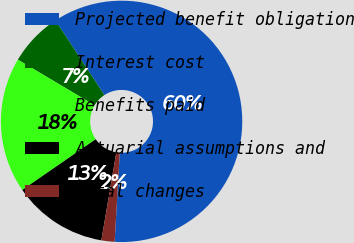Convert chart. <chart><loc_0><loc_0><loc_500><loc_500><pie_chart><fcel>Projected benefit obligation<fcel>Interest cost<fcel>Benefits paid<fcel>Actuarial assumptions and<fcel>Total changes<nl><fcel>60.15%<fcel>7.23%<fcel>18.16%<fcel>12.7%<fcel>1.76%<nl></chart> 